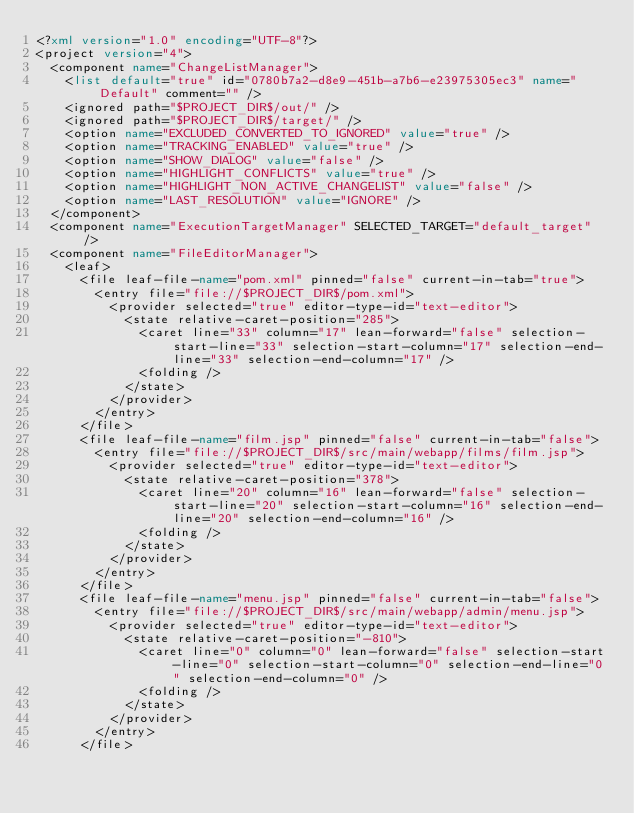<code> <loc_0><loc_0><loc_500><loc_500><_XML_><?xml version="1.0" encoding="UTF-8"?>
<project version="4">
  <component name="ChangeListManager">
    <list default="true" id="0780b7a2-d8e9-451b-a7b6-e23975305ec3" name="Default" comment="" />
    <ignored path="$PROJECT_DIR$/out/" />
    <ignored path="$PROJECT_DIR$/target/" />
    <option name="EXCLUDED_CONVERTED_TO_IGNORED" value="true" />
    <option name="TRACKING_ENABLED" value="true" />
    <option name="SHOW_DIALOG" value="false" />
    <option name="HIGHLIGHT_CONFLICTS" value="true" />
    <option name="HIGHLIGHT_NON_ACTIVE_CHANGELIST" value="false" />
    <option name="LAST_RESOLUTION" value="IGNORE" />
  </component>
  <component name="ExecutionTargetManager" SELECTED_TARGET="default_target" />
  <component name="FileEditorManager">
    <leaf>
      <file leaf-file-name="pom.xml" pinned="false" current-in-tab="true">
        <entry file="file://$PROJECT_DIR$/pom.xml">
          <provider selected="true" editor-type-id="text-editor">
            <state relative-caret-position="285">
              <caret line="33" column="17" lean-forward="false" selection-start-line="33" selection-start-column="17" selection-end-line="33" selection-end-column="17" />
              <folding />
            </state>
          </provider>
        </entry>
      </file>
      <file leaf-file-name="film.jsp" pinned="false" current-in-tab="false">
        <entry file="file://$PROJECT_DIR$/src/main/webapp/films/film.jsp">
          <provider selected="true" editor-type-id="text-editor">
            <state relative-caret-position="378">
              <caret line="20" column="16" lean-forward="false" selection-start-line="20" selection-start-column="16" selection-end-line="20" selection-end-column="16" />
              <folding />
            </state>
          </provider>
        </entry>
      </file>
      <file leaf-file-name="menu.jsp" pinned="false" current-in-tab="false">
        <entry file="file://$PROJECT_DIR$/src/main/webapp/admin/menu.jsp">
          <provider selected="true" editor-type-id="text-editor">
            <state relative-caret-position="-810">
              <caret line="0" column="0" lean-forward="false" selection-start-line="0" selection-start-column="0" selection-end-line="0" selection-end-column="0" />
              <folding />
            </state>
          </provider>
        </entry>
      </file></code> 